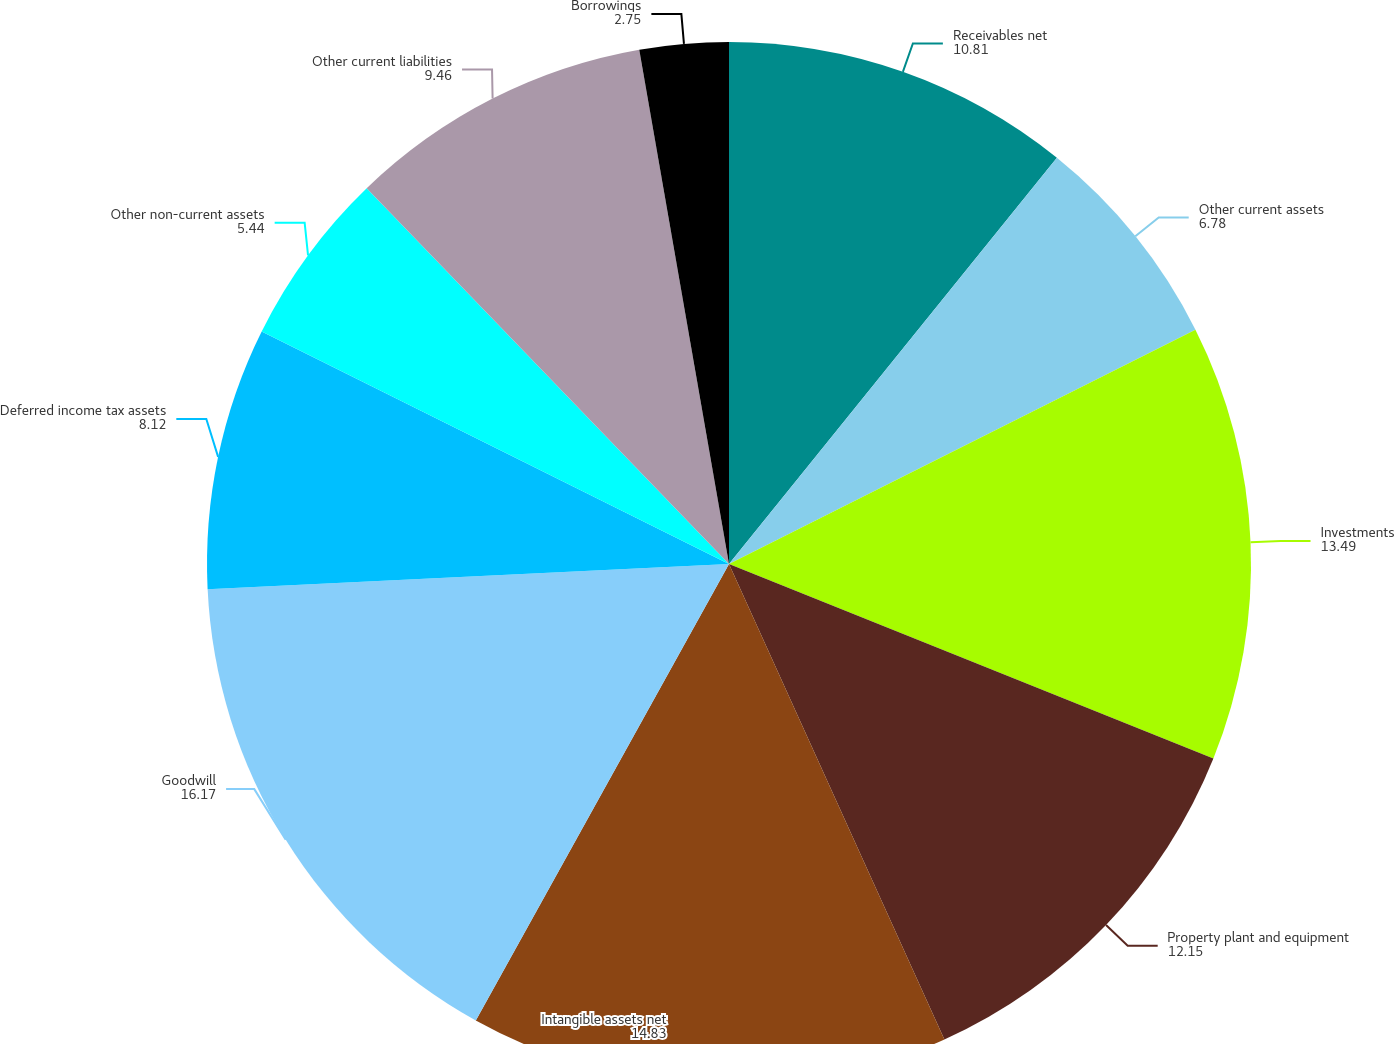Convert chart to OTSL. <chart><loc_0><loc_0><loc_500><loc_500><pie_chart><fcel>Receivables net<fcel>Other current assets<fcel>Investments<fcel>Property plant and equipment<fcel>Intangible assets net<fcel>Goodwill<fcel>Deferred income tax assets<fcel>Other non-current assets<fcel>Other current liabilities<fcel>Borrowings<nl><fcel>10.81%<fcel>6.78%<fcel>13.49%<fcel>12.15%<fcel>14.83%<fcel>16.17%<fcel>8.12%<fcel>5.44%<fcel>9.46%<fcel>2.75%<nl></chart> 